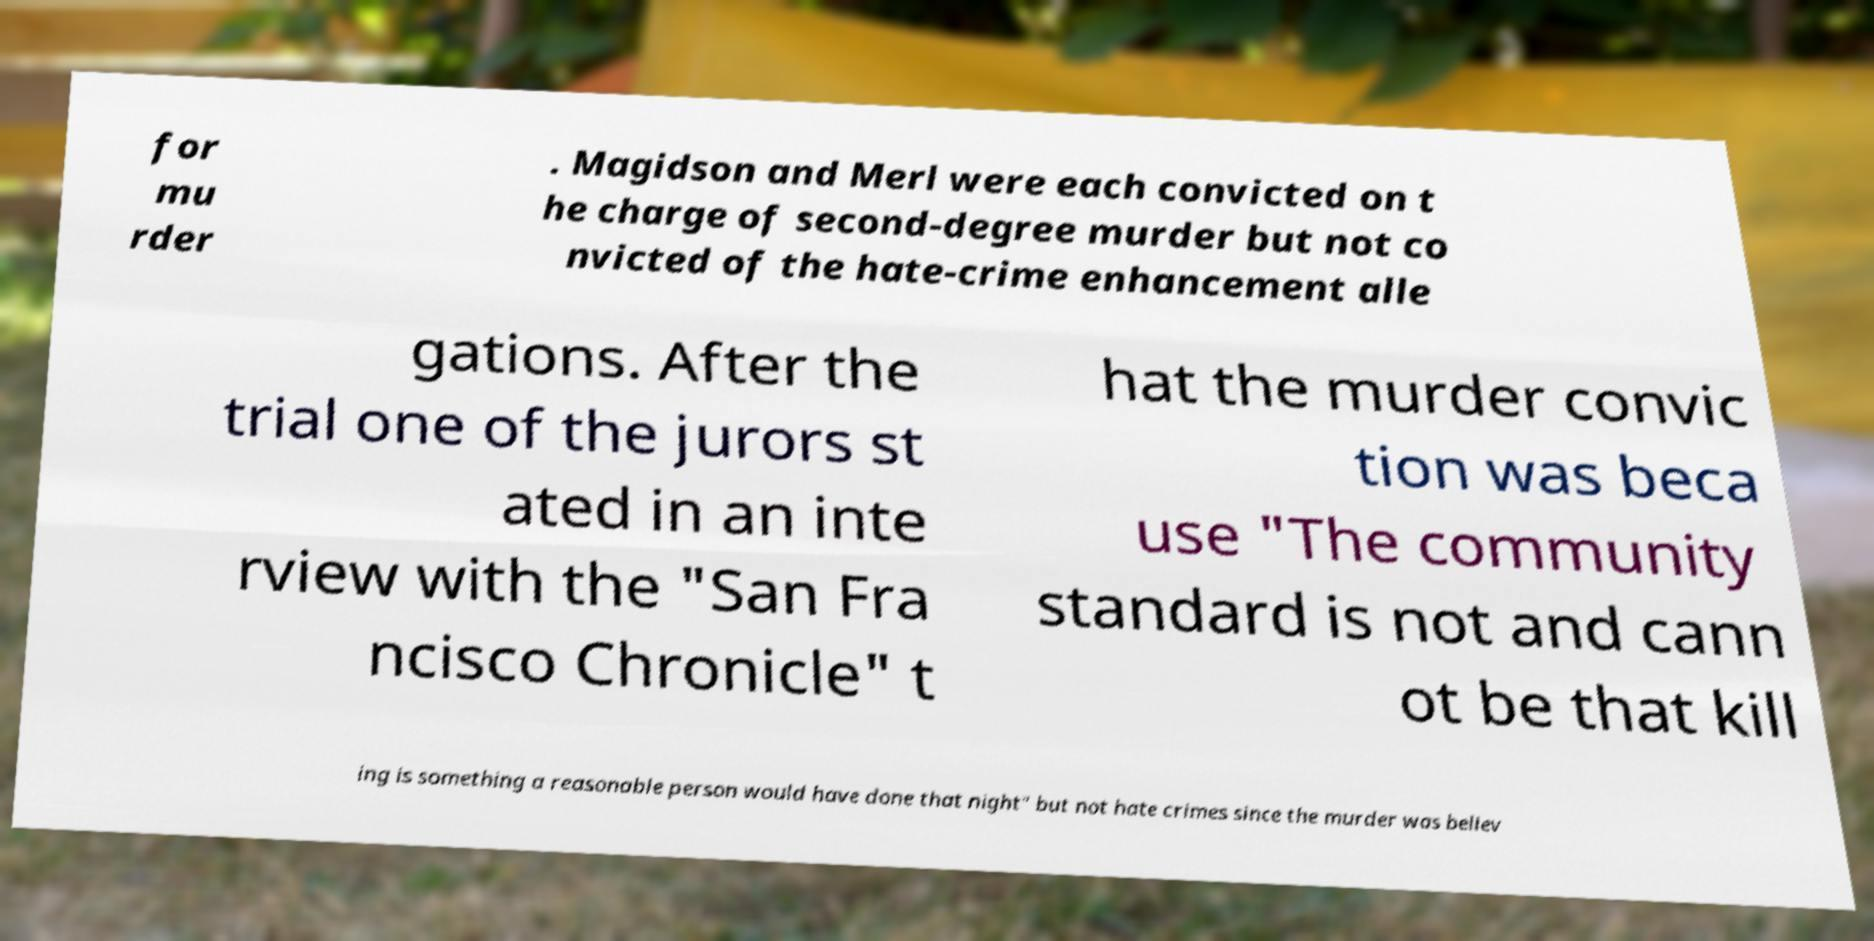Could you extract and type out the text from this image? for mu rder . Magidson and Merl were each convicted on t he charge of second-degree murder but not co nvicted of the hate-crime enhancement alle gations. After the trial one of the jurors st ated in an inte rview with the "San Fra ncisco Chronicle" t hat the murder convic tion was beca use "The community standard is not and cann ot be that kill ing is something a reasonable person would have done that night" but not hate crimes since the murder was believ 